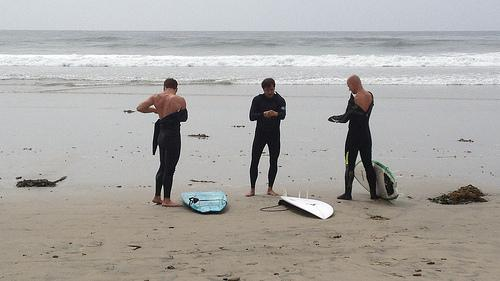Describe the image from the perspective of a person who just arrived at the scene. I've just arrived at the beach to find a beautiful vista: a gray sky meeting the dark blue ocean with white waves crashing on the shore. I can see three friends getting ready for a surf session, and I can't wait to join them. Write a poetic description of the image, using vivid imagery. Upon the rolling waves of steely gray, the eager trio dons their aquatic armor, ready to conquer the ocean's wild dance atop their vibrant steeds of water-bound delight. Describe the surface textures in the image and their visual impact. The coarse sand, the smooth and shiny wetsuits, the swirling seaweed, and the sleek surfboards create a visually diverse environment that captivates the viewer. Mention what stands out to you the most in the scene and what emotions it evokes. The sight of three friends preparing to surf on their colorful surfboards against the dark blue ocean and gray sky strikes me as a joyful adventure, full of excitement and camaraderie. Mention the prominent elements you see in the image, focusing on color and composition. The image features a light gray sky and a dark blue ocean with white waves, a sandy beach with seaweed, three men in wetsuits, and three surfboards - light blue, white, and green and white. Imagine you're a painter describing a scene you want to paint. Explain the main elements and their positions. I plan to paint a gray sky as the backdrop, an expansive dark blue ocean with white waves in the immediate foreground, a sandy shoreline with spiraled seaweed, and three men putting on wetsuits beside three colorful surfboards. Portray the actions taking place in the image by mentioning people, place, and objects. Men donning wetsuits, surfboards lying and standing nearby, and waves crashing along the shore prepare to make a splash on a sandy beach. Describe the scene using a short, catchy phrase. "Surf's up!" Three friends gear up for a ride on the ocean's rolling waves. Tell a brief story about the scene, including the characters and their intentions. Three friends arrived at the beach, eager to catch some waves. They hurriedly put on their wetsuits while glancing at the enticing ocean ahead. Soon, they would be zipping through the water on their vibrant surfboards. Use only adjectives to convey the atmosphere of the image. Gray, sandy, energetic, adventurous, bustling, wet, wavy, foamy, cool. 